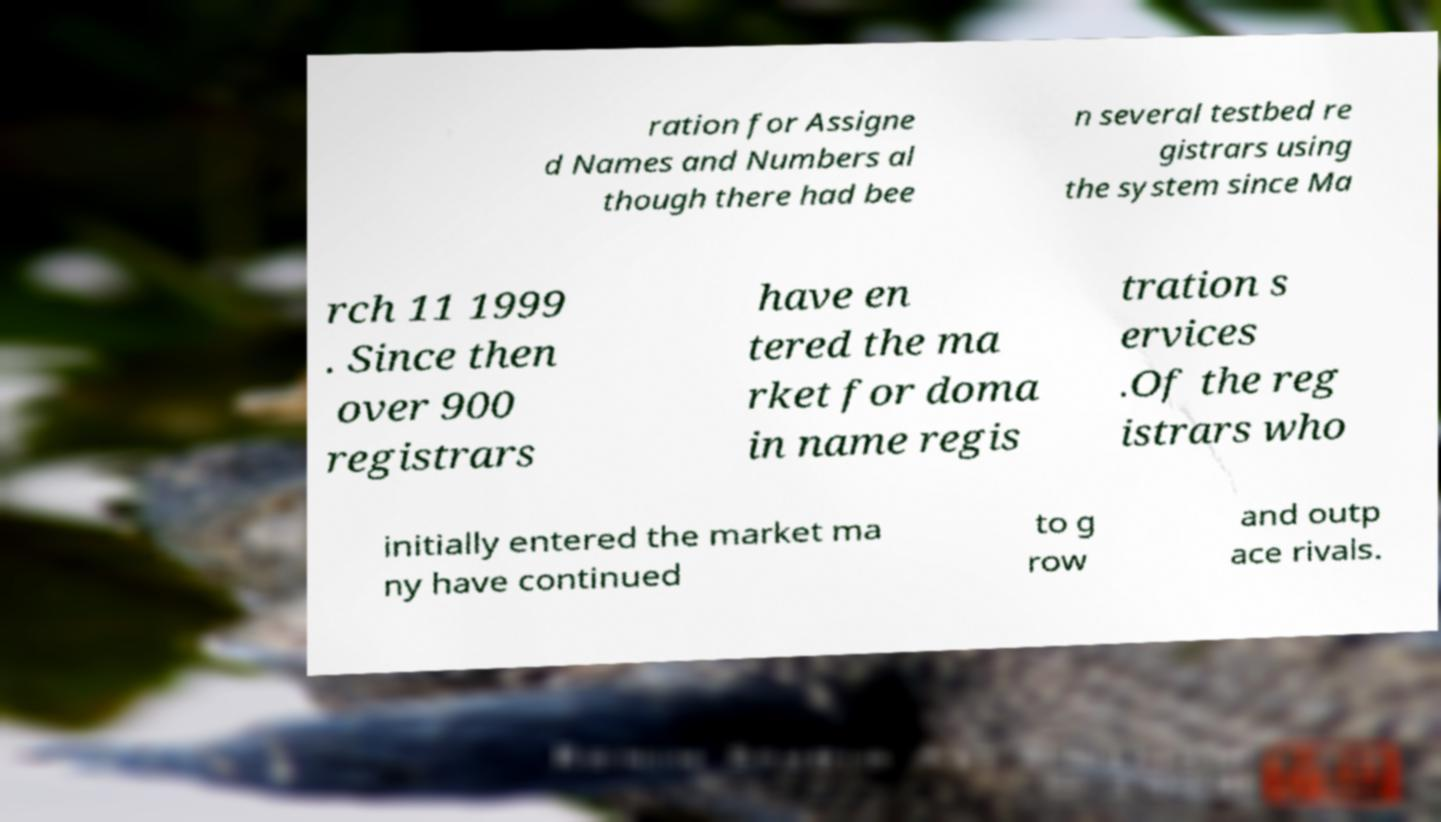Please read and relay the text visible in this image. What does it say? ration for Assigne d Names and Numbers al though there had bee n several testbed re gistrars using the system since Ma rch 11 1999 . Since then over 900 registrars have en tered the ma rket for doma in name regis tration s ervices .Of the reg istrars who initially entered the market ma ny have continued to g row and outp ace rivals. 